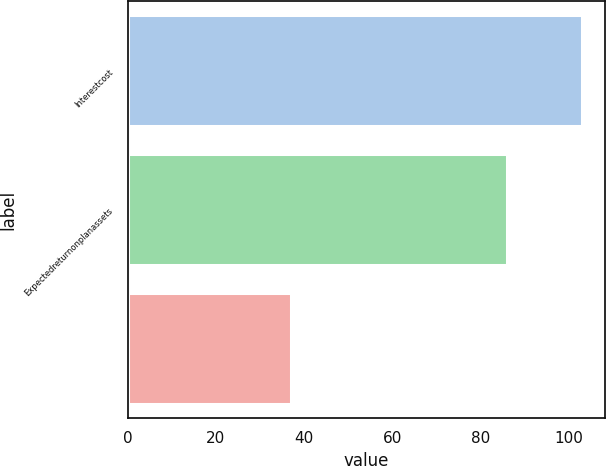<chart> <loc_0><loc_0><loc_500><loc_500><bar_chart><fcel>Interestcost<fcel>Expectedreturnonplanassets<fcel>Unnamed: 2<nl><fcel>103<fcel>86<fcel>37<nl></chart> 